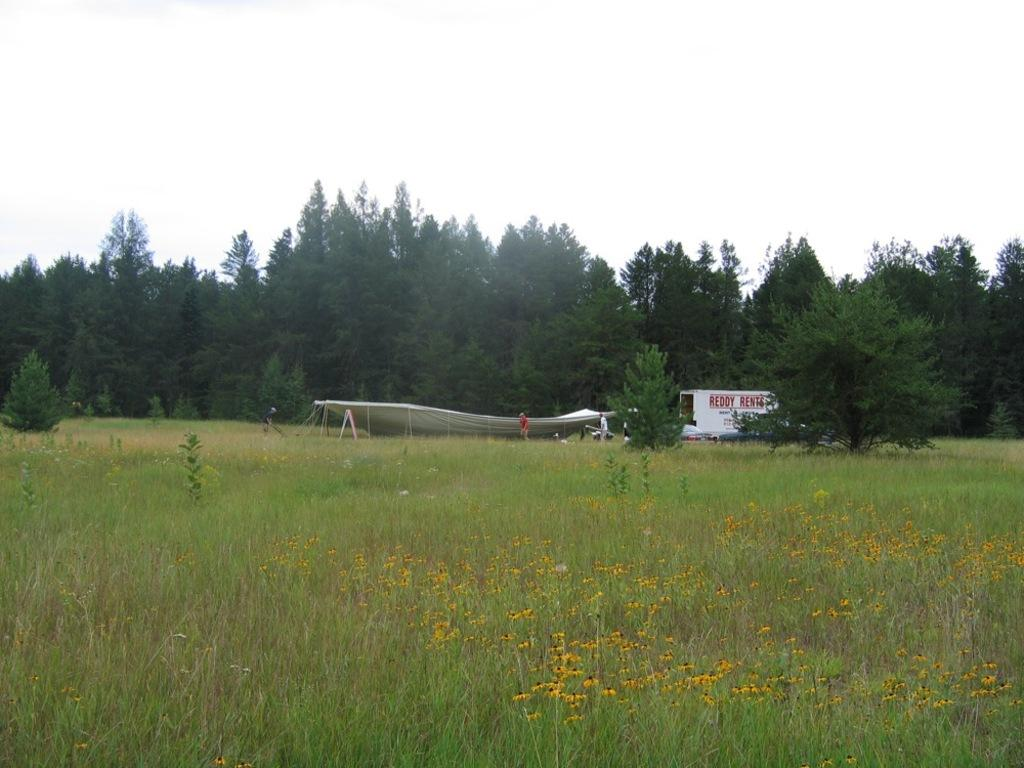What type of landscape is depicted in the image? There is a grassland in the image. What structure can be seen in the background of the image? There is a tent in the background of the image. What are the people in the image doing? There are persons standing in front of the tent. What other natural elements can be seen in the background of the image? There are trees visible in the background of the image. What is visible above the grassland and trees? The sky is visible in the image. How many bridges can be seen crossing the grassland in the image? There are no bridges visible in the image; it features a grassland with a tent and trees. What type of health advice can be seen on the tent in the image? There is no health advice present on the tent in the image; it is a tent without any visible text or information. 